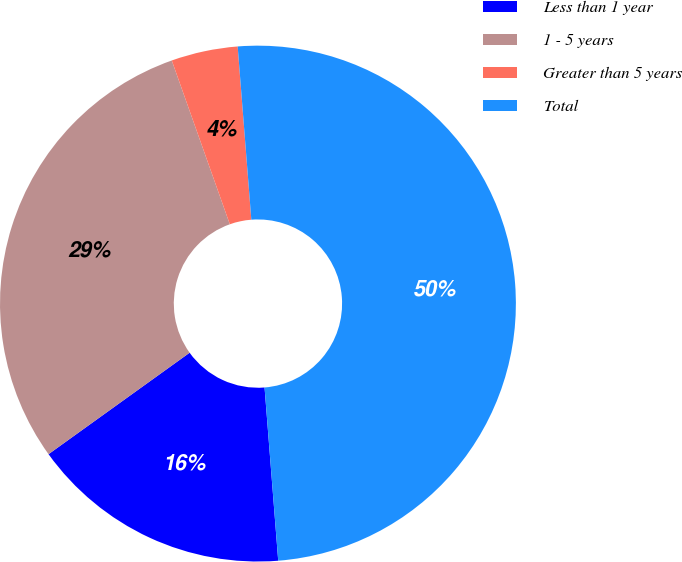<chart> <loc_0><loc_0><loc_500><loc_500><pie_chart><fcel>Less than 1 year<fcel>1 - 5 years<fcel>Greater than 5 years<fcel>Total<nl><fcel>16.33%<fcel>29.5%<fcel>4.17%<fcel>50.0%<nl></chart> 